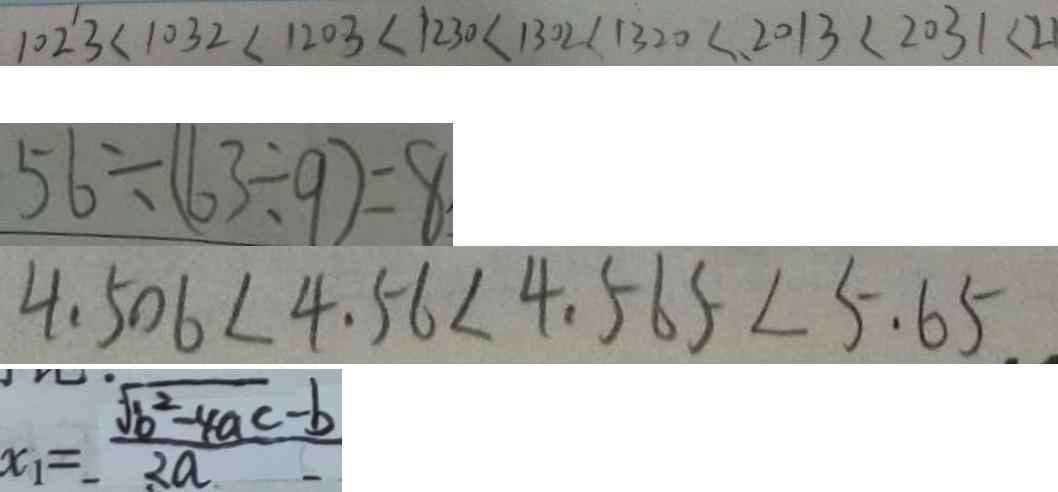Convert formula to latex. <formula><loc_0><loc_0><loc_500><loc_500>1 0 2 3 < 1 0 3 2 < 1 2 0 3 < 1 2 3 0 < 1 3 0 2 < 1 3 2 0 < 2 0 1 3 < 2 0 3 1 < 2 1 
 5 6 \div ( 6 3 \div 9 ) = 8 
 4 . 5 0 6 < 4 . 5 6 < 4 . 5 6 5 < 5 . 6 5 
 x _ { 1 } = \frac { \sqrt { b ^ { 2 } - 4 a c } - b } { 2 a }</formula> 